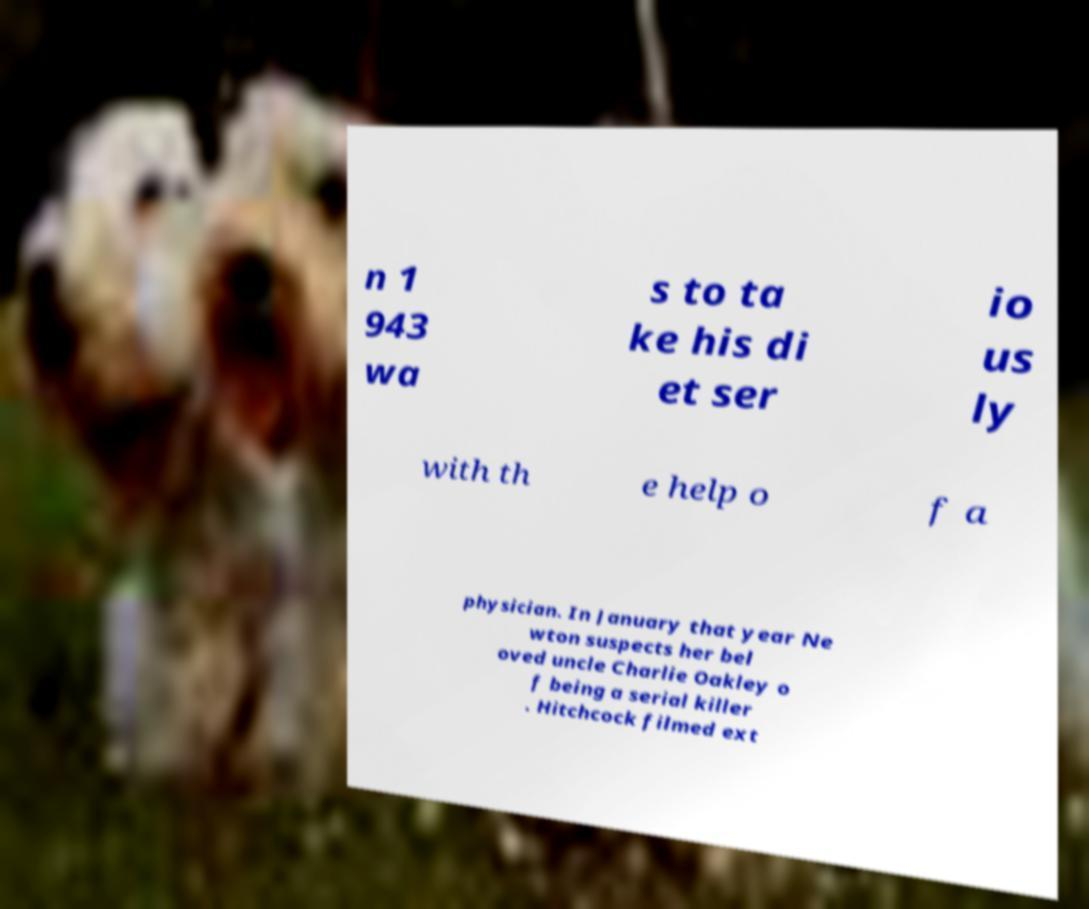Could you assist in decoding the text presented in this image and type it out clearly? n 1 943 wa s to ta ke his di et ser io us ly with th e help o f a physician. In January that year Ne wton suspects her bel oved uncle Charlie Oakley o f being a serial killer . Hitchcock filmed ext 